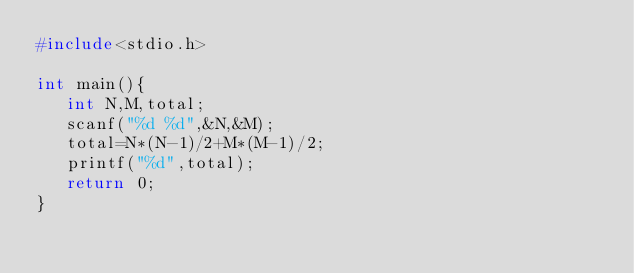Convert code to text. <code><loc_0><loc_0><loc_500><loc_500><_C_>#include<stdio.h>

int main(){
   int N,M,total;
   scanf("%d %d",&N,&M);
   total=N*(N-1)/2+M*(M-1)/2;
   printf("%d",total);
   return 0;
}
</code> 